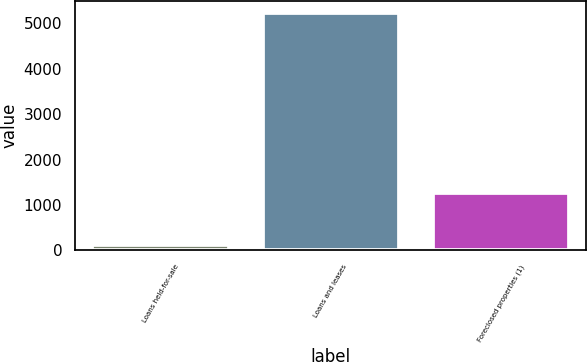<chart> <loc_0><loc_0><loc_500><loc_500><bar_chart><fcel>Loans held-for-sale<fcel>Loans and leases<fcel>Foreclosed properties (1)<nl><fcel>115<fcel>5240<fcel>1258<nl></chart> 